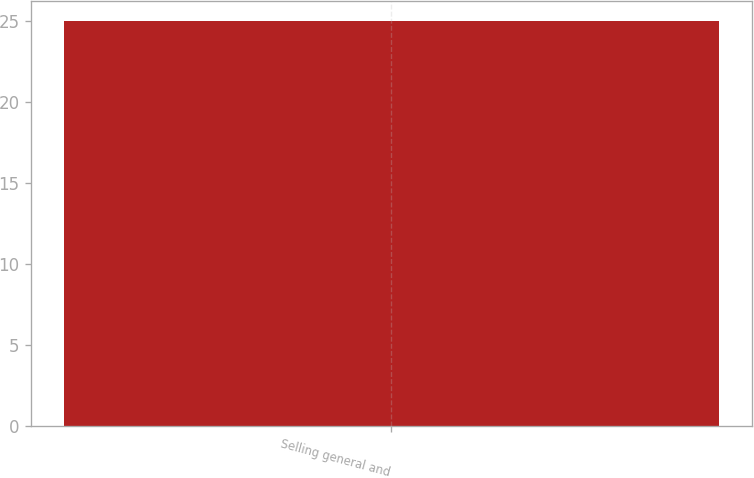Convert chart to OTSL. <chart><loc_0><loc_0><loc_500><loc_500><bar_chart><fcel>Selling general and<nl><fcel>25<nl></chart> 